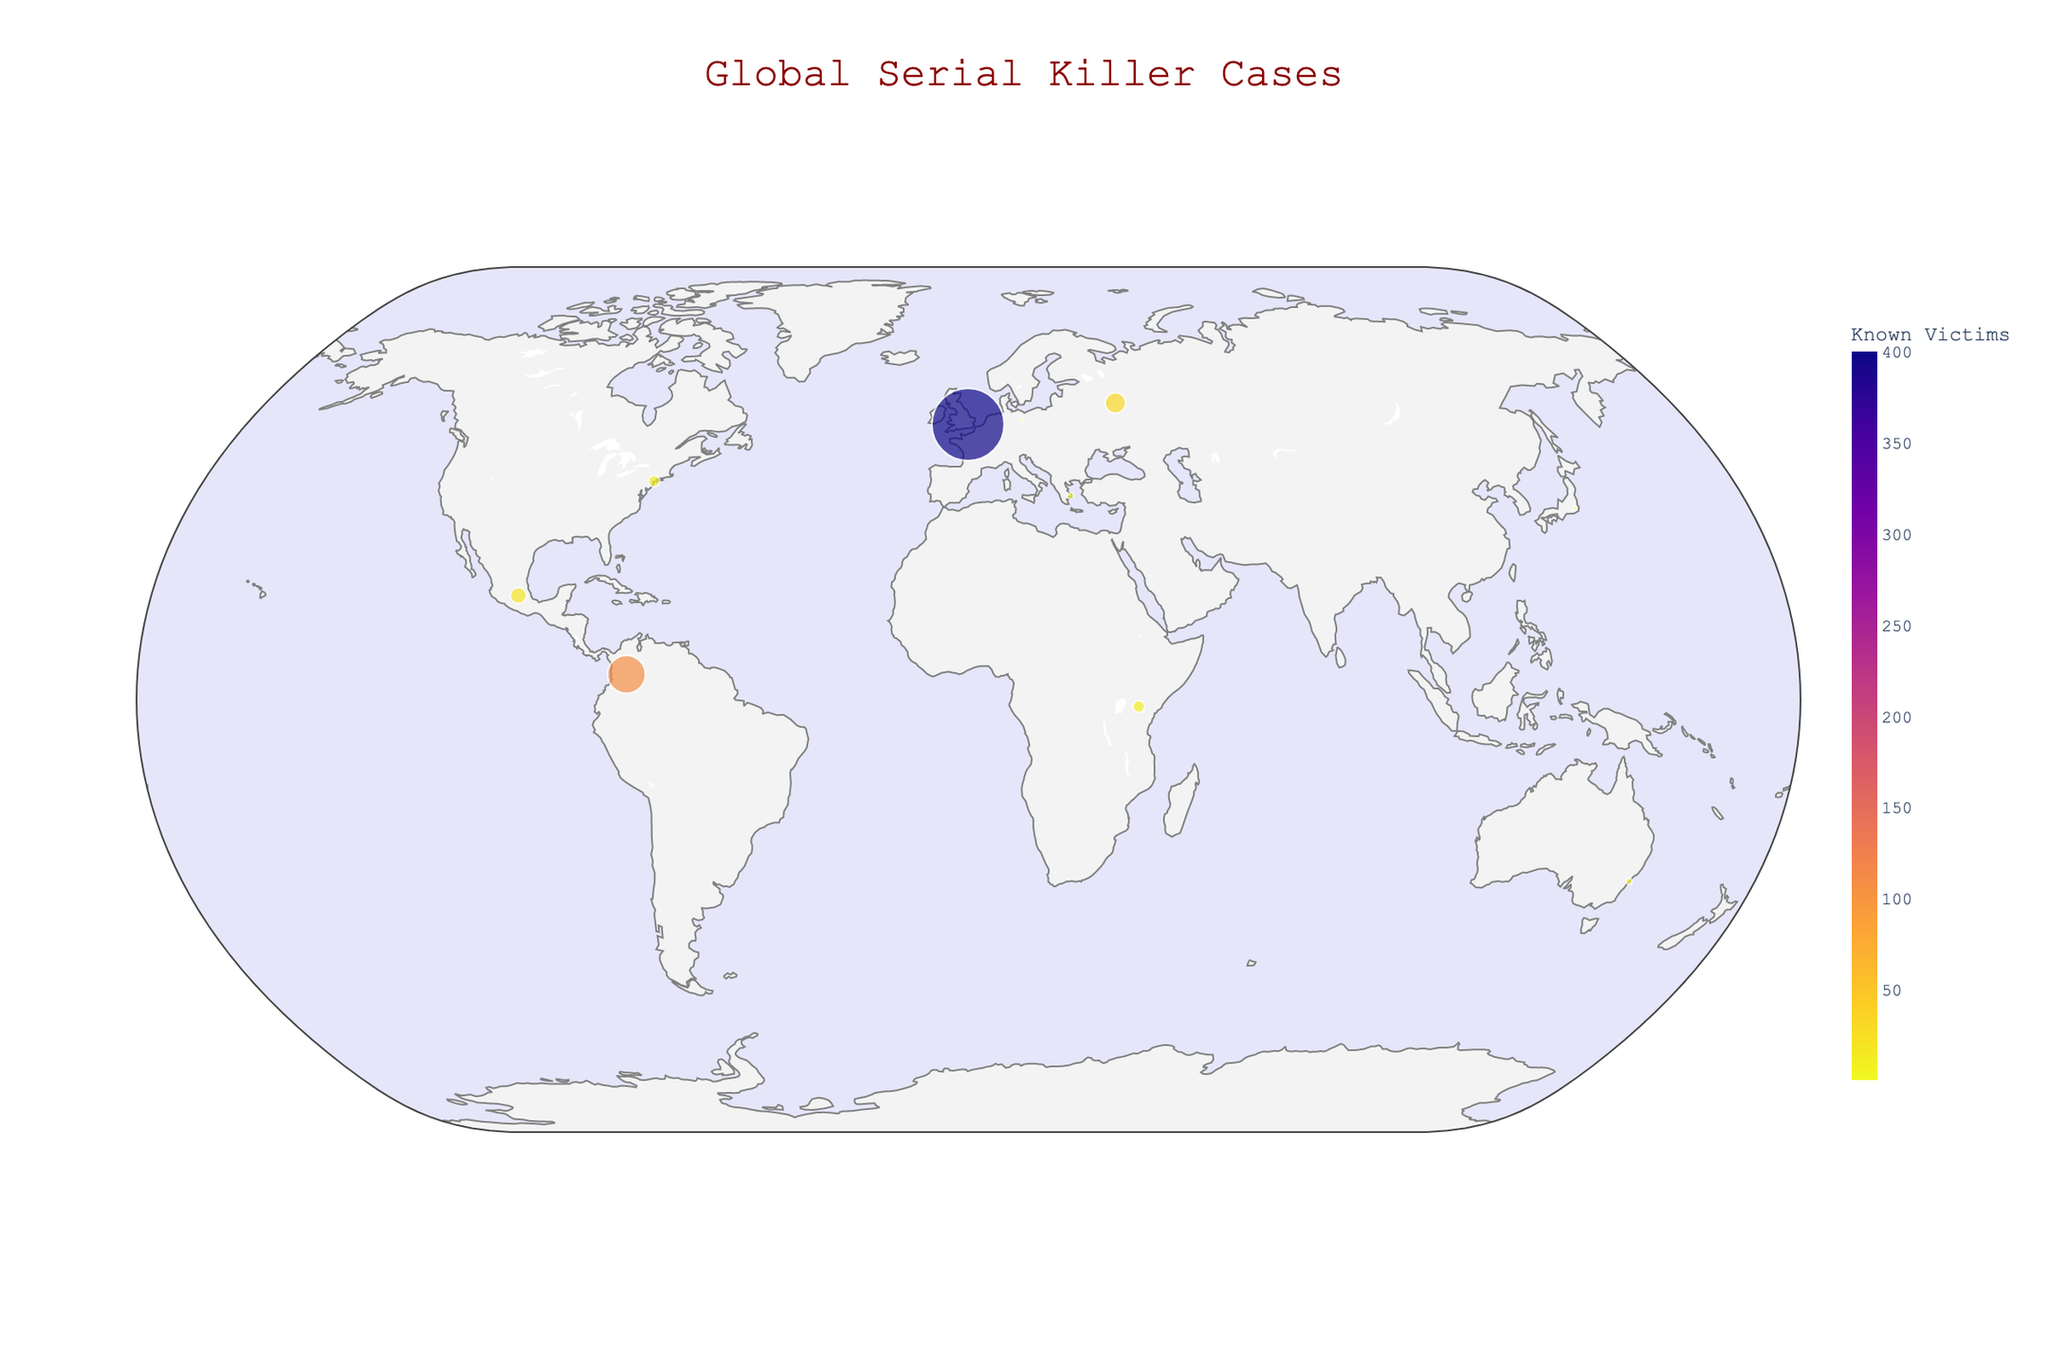What is the title of the map? The title of the map is usually displayed prominently at the top. For this map, it is in dark red color and reads "Global Serial Killer Cases."
Answer: Global Serial Killer Cases Which location has the highest number of known victims? The data points on the map use size and color to represent the number of known victims. The largest and darkest-colored point indicates the highest number of victims. In this case, it is Pedro López in Colombia with 110 known victims.
Answer: Pedro López in Colombia Which case is located at latitude 51.5074 and longitude -0.1278? By looking at the map and hovering over the specific coordinates (latitude 51.5074, longitude -0.1278), you can find the associated case. The case is the UK Animal Mutilations by The Croydon Cat Killer.
Answer: UK Animal Mutilations by The Croydon Cat Killer What is the most recent crime on the map? The map includes a timeline marker for each linked crime. The most recent crime would have the latest date. The Nairobi River Murders in Kenya happened on 2023-05-12.
Answer: Nairobi River Murders in Kenya How many known victims are attributed to the Long Island Serial Killer? Hovering over the Long Island Serial Killer's location on the map will provide information including the number of known victims, which is 10.
Answer: 10 Compare the number of known victims of The Athens Ripper and The Monster of Ecatepec. Which is higher? To compare, locate the points for The Athens Ripper and The Monster of Ecatepec. The Monster of Ecatepec has 20 known victims, which is higher than The Athens Ripper's 3 known victims.
Answer: The Monster of Ecatepec Which country has the earliest starting year for a serial killer case on the map? By reviewing the hover data of each point to note the start year, the earliest starting year is for Pedro López in Colombia, which began in 1969.
Answer: Colombia How many total known victims are represented on the map? Summing the known victims from each case: 10 (USA) + 400 (UK) + 32 (Russia) + 3 (Australia) + 1 (Japan) + 110 (Colombia) + 1 (Germany) + 3 (Greece) + 20 (Mexico) + 11 (Kenya) = 591.
Answer: 591 Which case has the smallest circle (representing the fewest known victims) on the map? The smallest circles represent cases with the fewest known victims. Both The Joker Killer in Japan and The Acid Killer in Germany have the smallest circles with 1 known victim each.
Answer: The Joker Killer in Japan and The Acid Killer in Germany 